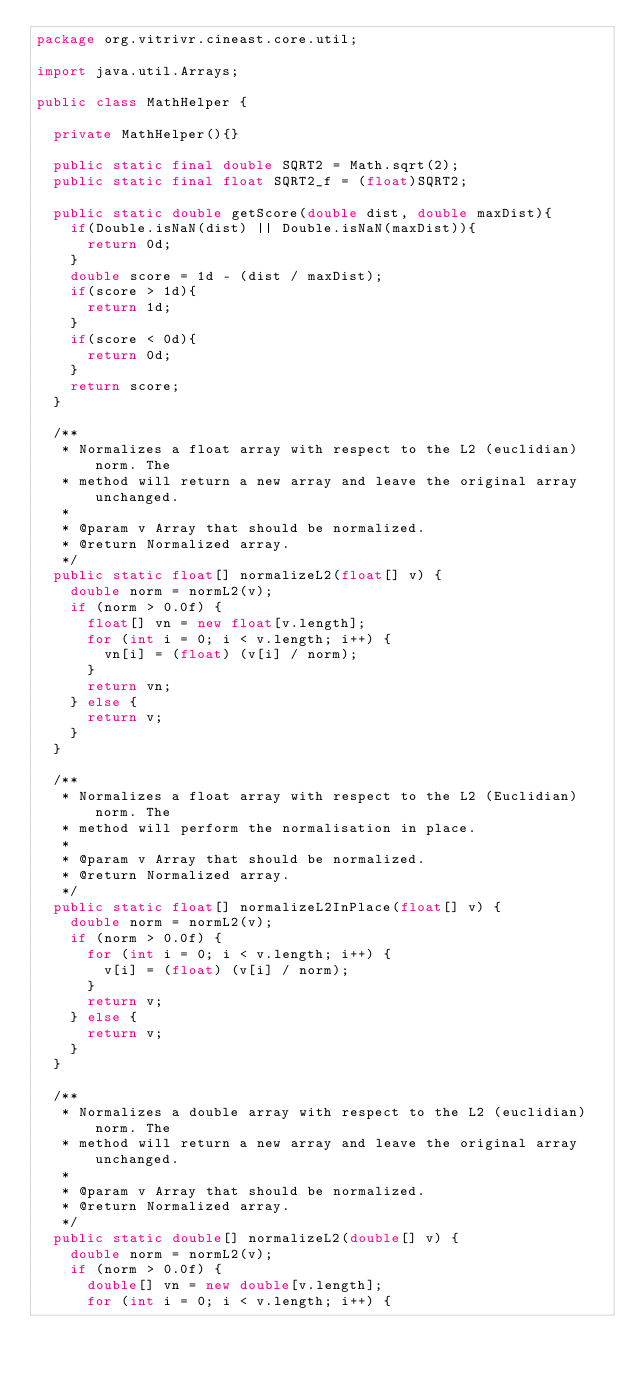Convert code to text. <code><loc_0><loc_0><loc_500><loc_500><_Java_>package org.vitrivr.cineast.core.util;

import java.util.Arrays;

public class MathHelper {

	private MathHelper(){}
	
	public static final double SQRT2 = Math.sqrt(2);
	public static final float SQRT2_f = (float)SQRT2;
	
	public static double getScore(double dist, double maxDist){
		if(Double.isNaN(dist) || Double.isNaN(maxDist)){
			return 0d;
		}
		double score = 1d - (dist / maxDist);
		if(score > 1d){
			return 1d;
		}
		if(score < 0d){
			return 0d;
		}
		return score;
	}

	/**
	 * Normalizes a float array with respect to the L2 (euclidian) norm. The
	 * method will return a new array and leave the original array unchanged.
	 *
	 * @param v Array that should be normalized.
	 * @return Normalized array.
	 */
	public static float[] normalizeL2(float[] v) {
		double norm = normL2(v);
		if (norm > 0.0f) {
			float[] vn = new float[v.length];
			for (int i = 0; i < v.length; i++) {
				vn[i] = (float) (v[i] / norm);
			}
			return vn;
		} else {
			return v;
		}
	}

	/**
	 * Normalizes a float array with respect to the L2 (Euclidian) norm. The
	 * method will perform the normalisation in place.
	 *
	 * @param v Array that should be normalized.
	 * @return Normalized array.
	 */
	public static float[] normalizeL2InPlace(float[] v) {
		double norm = normL2(v);
		if (norm > 0.0f) {
			for (int i = 0; i < v.length; i++) {
				v[i] = (float) (v[i] / norm);
			}
			return v;
		} else {
			return v;
		}
	}

	/**
	 * Normalizes a double array with respect to the L2 (euclidian) norm. The
	 * method will return a new array and leave the original array unchanged.
	 *
	 * @param v Array that should be normalized.
	 * @return Normalized array.
	 */
	public static double[] normalizeL2(double[] v) {
		double norm = normL2(v);
		if (norm > 0.0f) {
			double[] vn = new double[v.length];
			for (int i = 0; i < v.length; i++) {</code> 